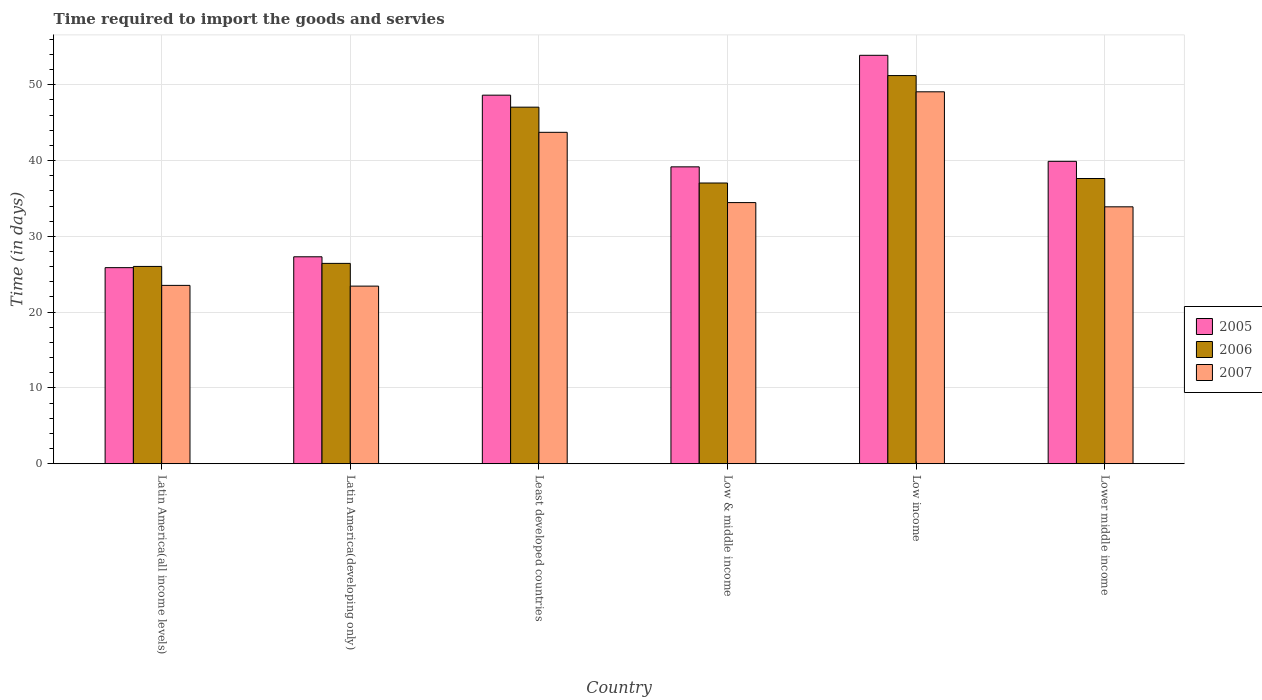How many different coloured bars are there?
Your answer should be very brief. 3. Are the number of bars per tick equal to the number of legend labels?
Your answer should be very brief. Yes. Are the number of bars on each tick of the X-axis equal?
Your answer should be very brief. Yes. How many bars are there on the 1st tick from the left?
Ensure brevity in your answer.  3. How many bars are there on the 1st tick from the right?
Ensure brevity in your answer.  3. What is the label of the 1st group of bars from the left?
Offer a very short reply. Latin America(all income levels). What is the number of days required to import the goods and services in 2006 in Lower middle income?
Your answer should be very brief. 37.63. Across all countries, what is the maximum number of days required to import the goods and services in 2007?
Keep it short and to the point. 49.07. Across all countries, what is the minimum number of days required to import the goods and services in 2007?
Your response must be concise. 23.43. In which country was the number of days required to import the goods and services in 2006 minimum?
Give a very brief answer. Latin America(all income levels). What is the total number of days required to import the goods and services in 2005 in the graph?
Provide a succinct answer. 234.76. What is the difference between the number of days required to import the goods and services in 2007 in Latin America(developing only) and that in Least developed countries?
Your response must be concise. -20.29. What is the difference between the number of days required to import the goods and services in 2007 in Least developed countries and the number of days required to import the goods and services in 2005 in Latin America(developing only)?
Make the answer very short. 16.42. What is the average number of days required to import the goods and services in 2007 per country?
Your answer should be compact. 34.69. What is the difference between the number of days required to import the goods and services of/in 2007 and number of days required to import the goods and services of/in 2006 in Least developed countries?
Provide a short and direct response. -3.32. In how many countries, is the number of days required to import the goods and services in 2007 greater than 4 days?
Offer a terse response. 6. What is the ratio of the number of days required to import the goods and services in 2007 in Least developed countries to that in Lower middle income?
Offer a terse response. 1.29. Is the difference between the number of days required to import the goods and services in 2007 in Low & middle income and Low income greater than the difference between the number of days required to import the goods and services in 2006 in Low & middle income and Low income?
Your answer should be very brief. No. What is the difference between the highest and the second highest number of days required to import the goods and services in 2007?
Your response must be concise. 14.62. What is the difference between the highest and the lowest number of days required to import the goods and services in 2006?
Provide a succinct answer. 25.18. Is the sum of the number of days required to import the goods and services in 2006 in Least developed countries and Low & middle income greater than the maximum number of days required to import the goods and services in 2005 across all countries?
Your answer should be compact. Yes. What does the 1st bar from the left in Least developed countries represents?
Your answer should be compact. 2005. How many countries are there in the graph?
Keep it short and to the point. 6. What is the difference between two consecutive major ticks on the Y-axis?
Offer a very short reply. 10. Are the values on the major ticks of Y-axis written in scientific E-notation?
Provide a short and direct response. No. Does the graph contain any zero values?
Provide a succinct answer. No. Does the graph contain grids?
Provide a short and direct response. Yes. How are the legend labels stacked?
Give a very brief answer. Vertical. What is the title of the graph?
Keep it short and to the point. Time required to import the goods and servies. What is the label or title of the X-axis?
Give a very brief answer. Country. What is the label or title of the Y-axis?
Your answer should be compact. Time (in days). What is the Time (in days) in 2005 in Latin America(all income levels)?
Give a very brief answer. 25.87. What is the Time (in days) in 2006 in Latin America(all income levels)?
Keep it short and to the point. 26.03. What is the Time (in days) in 2007 in Latin America(all income levels)?
Provide a short and direct response. 23.53. What is the Time (in days) in 2005 in Latin America(developing only)?
Your answer should be very brief. 27.3. What is the Time (in days) of 2006 in Latin America(developing only)?
Your answer should be compact. 26.43. What is the Time (in days) in 2007 in Latin America(developing only)?
Your answer should be compact. 23.43. What is the Time (in days) of 2005 in Least developed countries?
Provide a short and direct response. 48.63. What is the Time (in days) of 2006 in Least developed countries?
Provide a succinct answer. 47.05. What is the Time (in days) of 2007 in Least developed countries?
Keep it short and to the point. 43.73. What is the Time (in days) in 2005 in Low & middle income?
Offer a very short reply. 39.17. What is the Time (in days) in 2006 in Low & middle income?
Provide a succinct answer. 37.04. What is the Time (in days) in 2007 in Low & middle income?
Your response must be concise. 34.46. What is the Time (in days) of 2005 in Low income?
Offer a terse response. 53.89. What is the Time (in days) in 2006 in Low income?
Give a very brief answer. 51.21. What is the Time (in days) in 2007 in Low income?
Your response must be concise. 49.07. What is the Time (in days) of 2005 in Lower middle income?
Your response must be concise. 39.9. What is the Time (in days) of 2006 in Lower middle income?
Your response must be concise. 37.63. What is the Time (in days) in 2007 in Lower middle income?
Your response must be concise. 33.9. Across all countries, what is the maximum Time (in days) in 2005?
Provide a succinct answer. 53.89. Across all countries, what is the maximum Time (in days) of 2006?
Offer a very short reply. 51.21. Across all countries, what is the maximum Time (in days) in 2007?
Your response must be concise. 49.07. Across all countries, what is the minimum Time (in days) of 2005?
Your answer should be compact. 25.87. Across all countries, what is the minimum Time (in days) of 2006?
Make the answer very short. 26.03. Across all countries, what is the minimum Time (in days) of 2007?
Your response must be concise. 23.43. What is the total Time (in days) of 2005 in the graph?
Provide a short and direct response. 234.76. What is the total Time (in days) of 2006 in the graph?
Keep it short and to the point. 225.4. What is the total Time (in days) of 2007 in the graph?
Give a very brief answer. 208.12. What is the difference between the Time (in days) in 2005 in Latin America(all income levels) and that in Latin America(developing only)?
Offer a terse response. -1.43. What is the difference between the Time (in days) in 2006 in Latin America(all income levels) and that in Latin America(developing only)?
Offer a terse response. -0.4. What is the difference between the Time (in days) of 2007 in Latin America(all income levels) and that in Latin America(developing only)?
Your response must be concise. 0.1. What is the difference between the Time (in days) in 2005 in Latin America(all income levels) and that in Least developed countries?
Offer a very short reply. -22.76. What is the difference between the Time (in days) in 2006 in Latin America(all income levels) and that in Least developed countries?
Make the answer very short. -21.01. What is the difference between the Time (in days) in 2007 in Latin America(all income levels) and that in Least developed countries?
Offer a very short reply. -20.2. What is the difference between the Time (in days) in 2005 in Latin America(all income levels) and that in Low & middle income?
Ensure brevity in your answer.  -13.3. What is the difference between the Time (in days) in 2006 in Latin America(all income levels) and that in Low & middle income?
Keep it short and to the point. -11.01. What is the difference between the Time (in days) in 2007 in Latin America(all income levels) and that in Low & middle income?
Provide a short and direct response. -10.92. What is the difference between the Time (in days) in 2005 in Latin America(all income levels) and that in Low income?
Provide a short and direct response. -28.02. What is the difference between the Time (in days) in 2006 in Latin America(all income levels) and that in Low income?
Offer a terse response. -25.18. What is the difference between the Time (in days) in 2007 in Latin America(all income levels) and that in Low income?
Keep it short and to the point. -25.54. What is the difference between the Time (in days) in 2005 in Latin America(all income levels) and that in Lower middle income?
Offer a terse response. -14.03. What is the difference between the Time (in days) in 2006 in Latin America(all income levels) and that in Lower middle income?
Provide a succinct answer. -11.6. What is the difference between the Time (in days) of 2007 in Latin America(all income levels) and that in Lower middle income?
Provide a short and direct response. -10.37. What is the difference between the Time (in days) of 2005 in Latin America(developing only) and that in Least developed countries?
Keep it short and to the point. -21.32. What is the difference between the Time (in days) in 2006 in Latin America(developing only) and that in Least developed countries?
Give a very brief answer. -20.61. What is the difference between the Time (in days) in 2007 in Latin America(developing only) and that in Least developed countries?
Offer a very short reply. -20.29. What is the difference between the Time (in days) of 2005 in Latin America(developing only) and that in Low & middle income?
Give a very brief answer. -11.87. What is the difference between the Time (in days) of 2006 in Latin America(developing only) and that in Low & middle income?
Give a very brief answer. -10.61. What is the difference between the Time (in days) in 2007 in Latin America(developing only) and that in Low & middle income?
Give a very brief answer. -11.02. What is the difference between the Time (in days) in 2005 in Latin America(developing only) and that in Low income?
Your response must be concise. -26.58. What is the difference between the Time (in days) in 2006 in Latin America(developing only) and that in Low income?
Offer a very short reply. -24.78. What is the difference between the Time (in days) of 2007 in Latin America(developing only) and that in Low income?
Your answer should be compact. -25.64. What is the difference between the Time (in days) of 2005 in Latin America(developing only) and that in Lower middle income?
Offer a terse response. -12.59. What is the difference between the Time (in days) in 2006 in Latin America(developing only) and that in Lower middle income?
Your response must be concise. -11.2. What is the difference between the Time (in days) of 2007 in Latin America(developing only) and that in Lower middle income?
Ensure brevity in your answer.  -10.46. What is the difference between the Time (in days) of 2005 in Least developed countries and that in Low & middle income?
Ensure brevity in your answer.  9.46. What is the difference between the Time (in days) of 2006 in Least developed countries and that in Low & middle income?
Your answer should be very brief. 10.01. What is the difference between the Time (in days) in 2007 in Least developed countries and that in Low & middle income?
Offer a terse response. 9.27. What is the difference between the Time (in days) in 2005 in Least developed countries and that in Low income?
Give a very brief answer. -5.26. What is the difference between the Time (in days) of 2006 in Least developed countries and that in Low income?
Your response must be concise. -4.17. What is the difference between the Time (in days) in 2007 in Least developed countries and that in Low income?
Your response must be concise. -5.34. What is the difference between the Time (in days) in 2005 in Least developed countries and that in Lower middle income?
Your answer should be very brief. 8.73. What is the difference between the Time (in days) of 2006 in Least developed countries and that in Lower middle income?
Your answer should be compact. 9.41. What is the difference between the Time (in days) of 2007 in Least developed countries and that in Lower middle income?
Provide a succinct answer. 9.83. What is the difference between the Time (in days) of 2005 in Low & middle income and that in Low income?
Give a very brief answer. -14.72. What is the difference between the Time (in days) in 2006 in Low & middle income and that in Low income?
Your answer should be compact. -14.17. What is the difference between the Time (in days) of 2007 in Low & middle income and that in Low income?
Make the answer very short. -14.62. What is the difference between the Time (in days) in 2005 in Low & middle income and that in Lower middle income?
Make the answer very short. -0.73. What is the difference between the Time (in days) of 2006 in Low & middle income and that in Lower middle income?
Your answer should be very brief. -0.59. What is the difference between the Time (in days) in 2007 in Low & middle income and that in Lower middle income?
Offer a very short reply. 0.56. What is the difference between the Time (in days) in 2005 in Low income and that in Lower middle income?
Your response must be concise. 13.99. What is the difference between the Time (in days) in 2006 in Low income and that in Lower middle income?
Make the answer very short. 13.58. What is the difference between the Time (in days) in 2007 in Low income and that in Lower middle income?
Your response must be concise. 15.17. What is the difference between the Time (in days) in 2005 in Latin America(all income levels) and the Time (in days) in 2006 in Latin America(developing only)?
Make the answer very short. -0.56. What is the difference between the Time (in days) in 2005 in Latin America(all income levels) and the Time (in days) in 2007 in Latin America(developing only)?
Your answer should be very brief. 2.44. What is the difference between the Time (in days) in 2006 in Latin America(all income levels) and the Time (in days) in 2007 in Latin America(developing only)?
Your answer should be compact. 2.6. What is the difference between the Time (in days) in 2005 in Latin America(all income levels) and the Time (in days) in 2006 in Least developed countries?
Provide a succinct answer. -21.17. What is the difference between the Time (in days) of 2005 in Latin America(all income levels) and the Time (in days) of 2007 in Least developed countries?
Provide a succinct answer. -17.86. What is the difference between the Time (in days) in 2006 in Latin America(all income levels) and the Time (in days) in 2007 in Least developed countries?
Make the answer very short. -17.7. What is the difference between the Time (in days) of 2005 in Latin America(all income levels) and the Time (in days) of 2006 in Low & middle income?
Your answer should be compact. -11.17. What is the difference between the Time (in days) of 2005 in Latin America(all income levels) and the Time (in days) of 2007 in Low & middle income?
Ensure brevity in your answer.  -8.59. What is the difference between the Time (in days) of 2006 in Latin America(all income levels) and the Time (in days) of 2007 in Low & middle income?
Offer a very short reply. -8.42. What is the difference between the Time (in days) of 2005 in Latin America(all income levels) and the Time (in days) of 2006 in Low income?
Offer a terse response. -25.34. What is the difference between the Time (in days) in 2005 in Latin America(all income levels) and the Time (in days) in 2007 in Low income?
Keep it short and to the point. -23.2. What is the difference between the Time (in days) of 2006 in Latin America(all income levels) and the Time (in days) of 2007 in Low income?
Your answer should be very brief. -23.04. What is the difference between the Time (in days) in 2005 in Latin America(all income levels) and the Time (in days) in 2006 in Lower middle income?
Your answer should be very brief. -11.76. What is the difference between the Time (in days) in 2005 in Latin America(all income levels) and the Time (in days) in 2007 in Lower middle income?
Make the answer very short. -8.03. What is the difference between the Time (in days) in 2006 in Latin America(all income levels) and the Time (in days) in 2007 in Lower middle income?
Offer a terse response. -7.87. What is the difference between the Time (in days) of 2005 in Latin America(developing only) and the Time (in days) of 2006 in Least developed countries?
Provide a short and direct response. -19.74. What is the difference between the Time (in days) in 2005 in Latin America(developing only) and the Time (in days) in 2007 in Least developed countries?
Offer a terse response. -16.42. What is the difference between the Time (in days) of 2006 in Latin America(developing only) and the Time (in days) of 2007 in Least developed countries?
Give a very brief answer. -17.29. What is the difference between the Time (in days) in 2005 in Latin America(developing only) and the Time (in days) in 2006 in Low & middle income?
Give a very brief answer. -9.74. What is the difference between the Time (in days) in 2005 in Latin America(developing only) and the Time (in days) in 2007 in Low & middle income?
Ensure brevity in your answer.  -7.15. What is the difference between the Time (in days) in 2006 in Latin America(developing only) and the Time (in days) in 2007 in Low & middle income?
Your answer should be very brief. -8.02. What is the difference between the Time (in days) in 2005 in Latin America(developing only) and the Time (in days) in 2006 in Low income?
Your response must be concise. -23.91. What is the difference between the Time (in days) of 2005 in Latin America(developing only) and the Time (in days) of 2007 in Low income?
Your response must be concise. -21.77. What is the difference between the Time (in days) in 2006 in Latin America(developing only) and the Time (in days) in 2007 in Low income?
Provide a succinct answer. -22.64. What is the difference between the Time (in days) in 2005 in Latin America(developing only) and the Time (in days) in 2006 in Lower middle income?
Offer a terse response. -10.33. What is the difference between the Time (in days) in 2005 in Latin America(developing only) and the Time (in days) in 2007 in Lower middle income?
Make the answer very short. -6.59. What is the difference between the Time (in days) in 2006 in Latin America(developing only) and the Time (in days) in 2007 in Lower middle income?
Offer a terse response. -7.46. What is the difference between the Time (in days) of 2005 in Least developed countries and the Time (in days) of 2006 in Low & middle income?
Your response must be concise. 11.59. What is the difference between the Time (in days) of 2005 in Least developed countries and the Time (in days) of 2007 in Low & middle income?
Provide a short and direct response. 14.17. What is the difference between the Time (in days) of 2006 in Least developed countries and the Time (in days) of 2007 in Low & middle income?
Ensure brevity in your answer.  12.59. What is the difference between the Time (in days) of 2005 in Least developed countries and the Time (in days) of 2006 in Low income?
Provide a succinct answer. -2.59. What is the difference between the Time (in days) of 2005 in Least developed countries and the Time (in days) of 2007 in Low income?
Your answer should be very brief. -0.44. What is the difference between the Time (in days) of 2006 in Least developed countries and the Time (in days) of 2007 in Low income?
Offer a very short reply. -2.03. What is the difference between the Time (in days) in 2005 in Least developed countries and the Time (in days) in 2006 in Lower middle income?
Your answer should be very brief. 11. What is the difference between the Time (in days) of 2005 in Least developed countries and the Time (in days) of 2007 in Lower middle income?
Provide a short and direct response. 14.73. What is the difference between the Time (in days) of 2006 in Least developed countries and the Time (in days) of 2007 in Lower middle income?
Give a very brief answer. 13.15. What is the difference between the Time (in days) in 2005 in Low & middle income and the Time (in days) in 2006 in Low income?
Offer a very short reply. -12.04. What is the difference between the Time (in days) of 2005 in Low & middle income and the Time (in days) of 2007 in Low income?
Your answer should be very brief. -9.9. What is the difference between the Time (in days) of 2006 in Low & middle income and the Time (in days) of 2007 in Low income?
Offer a terse response. -12.03. What is the difference between the Time (in days) of 2005 in Low & middle income and the Time (in days) of 2006 in Lower middle income?
Keep it short and to the point. 1.54. What is the difference between the Time (in days) of 2005 in Low & middle income and the Time (in days) of 2007 in Lower middle income?
Provide a succinct answer. 5.27. What is the difference between the Time (in days) in 2006 in Low & middle income and the Time (in days) in 2007 in Lower middle income?
Provide a short and direct response. 3.14. What is the difference between the Time (in days) in 2005 in Low income and the Time (in days) in 2006 in Lower middle income?
Your response must be concise. 16.26. What is the difference between the Time (in days) of 2005 in Low income and the Time (in days) of 2007 in Lower middle income?
Give a very brief answer. 19.99. What is the difference between the Time (in days) in 2006 in Low income and the Time (in days) in 2007 in Lower middle income?
Your answer should be compact. 17.32. What is the average Time (in days) of 2005 per country?
Your answer should be compact. 39.13. What is the average Time (in days) in 2006 per country?
Give a very brief answer. 37.57. What is the average Time (in days) of 2007 per country?
Give a very brief answer. 34.69. What is the difference between the Time (in days) of 2005 and Time (in days) of 2006 in Latin America(all income levels)?
Ensure brevity in your answer.  -0.16. What is the difference between the Time (in days) in 2005 and Time (in days) in 2007 in Latin America(all income levels)?
Your response must be concise. 2.34. What is the difference between the Time (in days) of 2006 and Time (in days) of 2007 in Latin America(all income levels)?
Your response must be concise. 2.5. What is the difference between the Time (in days) of 2005 and Time (in days) of 2006 in Latin America(developing only)?
Provide a short and direct response. 0.87. What is the difference between the Time (in days) of 2005 and Time (in days) of 2007 in Latin America(developing only)?
Your answer should be compact. 3.87. What is the difference between the Time (in days) in 2005 and Time (in days) in 2006 in Least developed countries?
Your response must be concise. 1.58. What is the difference between the Time (in days) in 2005 and Time (in days) in 2007 in Least developed countries?
Your answer should be very brief. 4.9. What is the difference between the Time (in days) in 2006 and Time (in days) in 2007 in Least developed countries?
Ensure brevity in your answer.  3.32. What is the difference between the Time (in days) of 2005 and Time (in days) of 2006 in Low & middle income?
Your answer should be very brief. 2.13. What is the difference between the Time (in days) of 2005 and Time (in days) of 2007 in Low & middle income?
Provide a short and direct response. 4.71. What is the difference between the Time (in days) in 2006 and Time (in days) in 2007 in Low & middle income?
Provide a short and direct response. 2.58. What is the difference between the Time (in days) in 2005 and Time (in days) in 2006 in Low income?
Your answer should be compact. 2.67. What is the difference between the Time (in days) in 2005 and Time (in days) in 2007 in Low income?
Make the answer very short. 4.82. What is the difference between the Time (in days) in 2006 and Time (in days) in 2007 in Low income?
Your answer should be very brief. 2.14. What is the difference between the Time (in days) of 2005 and Time (in days) of 2006 in Lower middle income?
Your response must be concise. 2.27. What is the difference between the Time (in days) of 2005 and Time (in days) of 2007 in Lower middle income?
Offer a very short reply. 6. What is the difference between the Time (in days) in 2006 and Time (in days) in 2007 in Lower middle income?
Provide a succinct answer. 3.73. What is the ratio of the Time (in days) of 2005 in Latin America(all income levels) to that in Latin America(developing only)?
Provide a short and direct response. 0.95. What is the ratio of the Time (in days) of 2005 in Latin America(all income levels) to that in Least developed countries?
Provide a succinct answer. 0.53. What is the ratio of the Time (in days) in 2006 in Latin America(all income levels) to that in Least developed countries?
Offer a terse response. 0.55. What is the ratio of the Time (in days) in 2007 in Latin America(all income levels) to that in Least developed countries?
Keep it short and to the point. 0.54. What is the ratio of the Time (in days) of 2005 in Latin America(all income levels) to that in Low & middle income?
Provide a succinct answer. 0.66. What is the ratio of the Time (in days) in 2006 in Latin America(all income levels) to that in Low & middle income?
Keep it short and to the point. 0.7. What is the ratio of the Time (in days) of 2007 in Latin America(all income levels) to that in Low & middle income?
Your response must be concise. 0.68. What is the ratio of the Time (in days) of 2005 in Latin America(all income levels) to that in Low income?
Your answer should be compact. 0.48. What is the ratio of the Time (in days) of 2006 in Latin America(all income levels) to that in Low income?
Provide a succinct answer. 0.51. What is the ratio of the Time (in days) in 2007 in Latin America(all income levels) to that in Low income?
Offer a terse response. 0.48. What is the ratio of the Time (in days) of 2005 in Latin America(all income levels) to that in Lower middle income?
Offer a terse response. 0.65. What is the ratio of the Time (in days) of 2006 in Latin America(all income levels) to that in Lower middle income?
Provide a succinct answer. 0.69. What is the ratio of the Time (in days) in 2007 in Latin America(all income levels) to that in Lower middle income?
Ensure brevity in your answer.  0.69. What is the ratio of the Time (in days) in 2005 in Latin America(developing only) to that in Least developed countries?
Your answer should be very brief. 0.56. What is the ratio of the Time (in days) in 2006 in Latin America(developing only) to that in Least developed countries?
Your answer should be very brief. 0.56. What is the ratio of the Time (in days) of 2007 in Latin America(developing only) to that in Least developed countries?
Make the answer very short. 0.54. What is the ratio of the Time (in days) of 2005 in Latin America(developing only) to that in Low & middle income?
Your response must be concise. 0.7. What is the ratio of the Time (in days) of 2006 in Latin America(developing only) to that in Low & middle income?
Your answer should be compact. 0.71. What is the ratio of the Time (in days) of 2007 in Latin America(developing only) to that in Low & middle income?
Provide a succinct answer. 0.68. What is the ratio of the Time (in days) of 2005 in Latin America(developing only) to that in Low income?
Offer a very short reply. 0.51. What is the ratio of the Time (in days) in 2006 in Latin America(developing only) to that in Low income?
Offer a terse response. 0.52. What is the ratio of the Time (in days) in 2007 in Latin America(developing only) to that in Low income?
Keep it short and to the point. 0.48. What is the ratio of the Time (in days) in 2005 in Latin America(developing only) to that in Lower middle income?
Your answer should be compact. 0.68. What is the ratio of the Time (in days) in 2006 in Latin America(developing only) to that in Lower middle income?
Provide a short and direct response. 0.7. What is the ratio of the Time (in days) of 2007 in Latin America(developing only) to that in Lower middle income?
Ensure brevity in your answer.  0.69. What is the ratio of the Time (in days) of 2005 in Least developed countries to that in Low & middle income?
Give a very brief answer. 1.24. What is the ratio of the Time (in days) of 2006 in Least developed countries to that in Low & middle income?
Offer a terse response. 1.27. What is the ratio of the Time (in days) in 2007 in Least developed countries to that in Low & middle income?
Provide a succinct answer. 1.27. What is the ratio of the Time (in days) of 2005 in Least developed countries to that in Low income?
Provide a succinct answer. 0.9. What is the ratio of the Time (in days) of 2006 in Least developed countries to that in Low income?
Offer a very short reply. 0.92. What is the ratio of the Time (in days) in 2007 in Least developed countries to that in Low income?
Make the answer very short. 0.89. What is the ratio of the Time (in days) of 2005 in Least developed countries to that in Lower middle income?
Your response must be concise. 1.22. What is the ratio of the Time (in days) of 2006 in Least developed countries to that in Lower middle income?
Offer a terse response. 1.25. What is the ratio of the Time (in days) of 2007 in Least developed countries to that in Lower middle income?
Offer a terse response. 1.29. What is the ratio of the Time (in days) in 2005 in Low & middle income to that in Low income?
Your response must be concise. 0.73. What is the ratio of the Time (in days) in 2006 in Low & middle income to that in Low income?
Give a very brief answer. 0.72. What is the ratio of the Time (in days) in 2007 in Low & middle income to that in Low income?
Give a very brief answer. 0.7. What is the ratio of the Time (in days) of 2005 in Low & middle income to that in Lower middle income?
Provide a succinct answer. 0.98. What is the ratio of the Time (in days) in 2006 in Low & middle income to that in Lower middle income?
Offer a terse response. 0.98. What is the ratio of the Time (in days) in 2007 in Low & middle income to that in Lower middle income?
Provide a short and direct response. 1.02. What is the ratio of the Time (in days) of 2005 in Low income to that in Lower middle income?
Make the answer very short. 1.35. What is the ratio of the Time (in days) of 2006 in Low income to that in Lower middle income?
Provide a short and direct response. 1.36. What is the ratio of the Time (in days) in 2007 in Low income to that in Lower middle income?
Give a very brief answer. 1.45. What is the difference between the highest and the second highest Time (in days) of 2005?
Make the answer very short. 5.26. What is the difference between the highest and the second highest Time (in days) in 2006?
Offer a terse response. 4.17. What is the difference between the highest and the second highest Time (in days) in 2007?
Your answer should be compact. 5.34. What is the difference between the highest and the lowest Time (in days) of 2005?
Your answer should be compact. 28.02. What is the difference between the highest and the lowest Time (in days) in 2006?
Provide a short and direct response. 25.18. What is the difference between the highest and the lowest Time (in days) of 2007?
Ensure brevity in your answer.  25.64. 